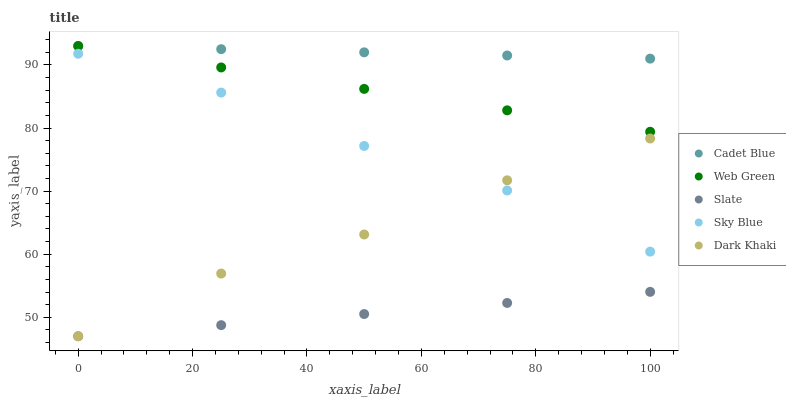Does Slate have the minimum area under the curve?
Answer yes or no. Yes. Does Cadet Blue have the maximum area under the curve?
Answer yes or no. Yes. Does Sky Blue have the minimum area under the curve?
Answer yes or no. No. Does Sky Blue have the maximum area under the curve?
Answer yes or no. No. Is Slate the smoothest?
Answer yes or no. Yes. Is Dark Khaki the roughest?
Answer yes or no. Yes. Is Sky Blue the smoothest?
Answer yes or no. No. Is Sky Blue the roughest?
Answer yes or no. No. Does Dark Khaki have the lowest value?
Answer yes or no. Yes. Does Sky Blue have the lowest value?
Answer yes or no. No. Does Web Green have the highest value?
Answer yes or no. Yes. Does Sky Blue have the highest value?
Answer yes or no. No. Is Sky Blue less than Web Green?
Answer yes or no. Yes. Is Sky Blue greater than Slate?
Answer yes or no. Yes. Does Dark Khaki intersect Sky Blue?
Answer yes or no. Yes. Is Dark Khaki less than Sky Blue?
Answer yes or no. No. Is Dark Khaki greater than Sky Blue?
Answer yes or no. No. Does Sky Blue intersect Web Green?
Answer yes or no. No. 